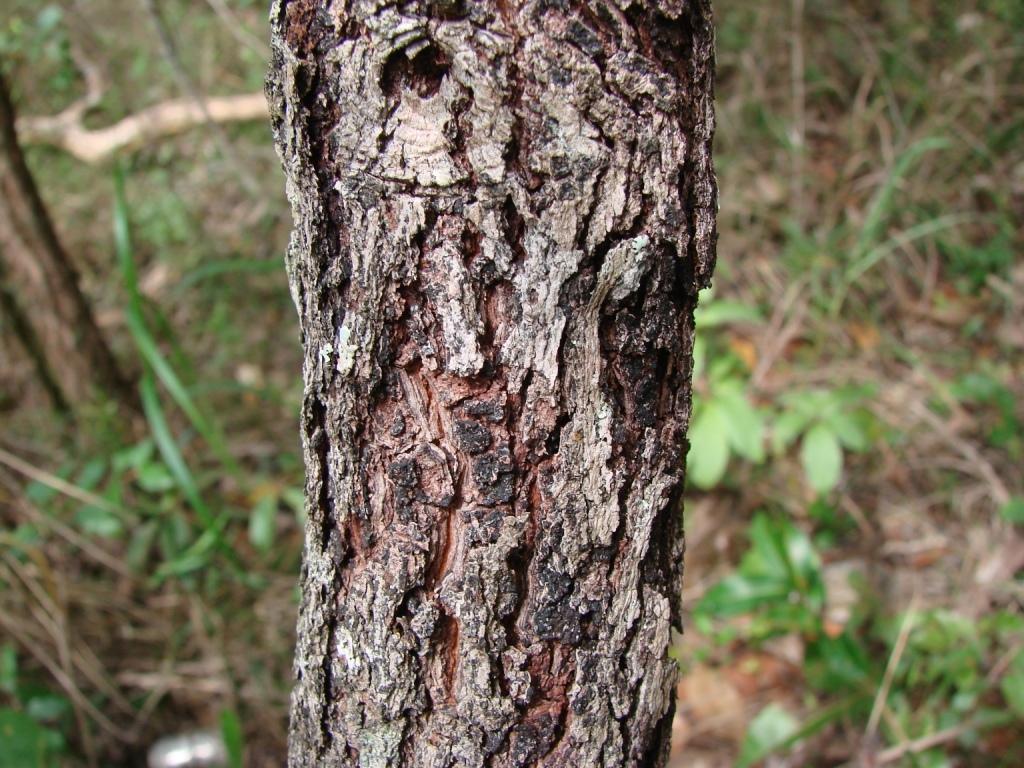How would you summarize this image in a sentence or two? In this image, we can see a tree trunk. In the background, there are plants and wooden objects. 